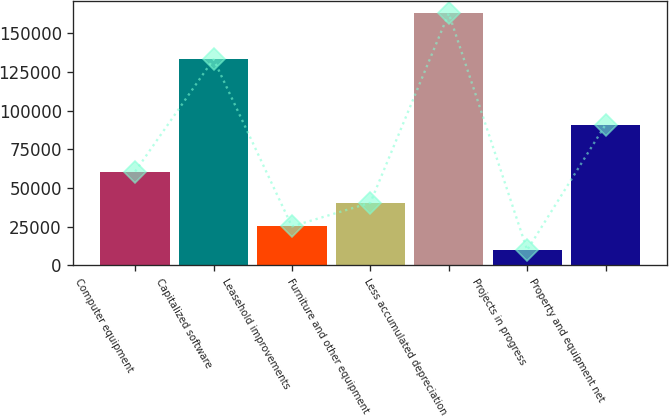Convert chart to OTSL. <chart><loc_0><loc_0><loc_500><loc_500><bar_chart><fcel>Computer equipment<fcel>Capitalized software<fcel>Leasehold improvements<fcel>Furniture and other equipment<fcel>Less accumulated depreciation<fcel>Projects in progress<fcel>Property and equipment net<nl><fcel>60648<fcel>133256<fcel>25142.5<fcel>40445<fcel>162865<fcel>9840<fcel>90984<nl></chart> 